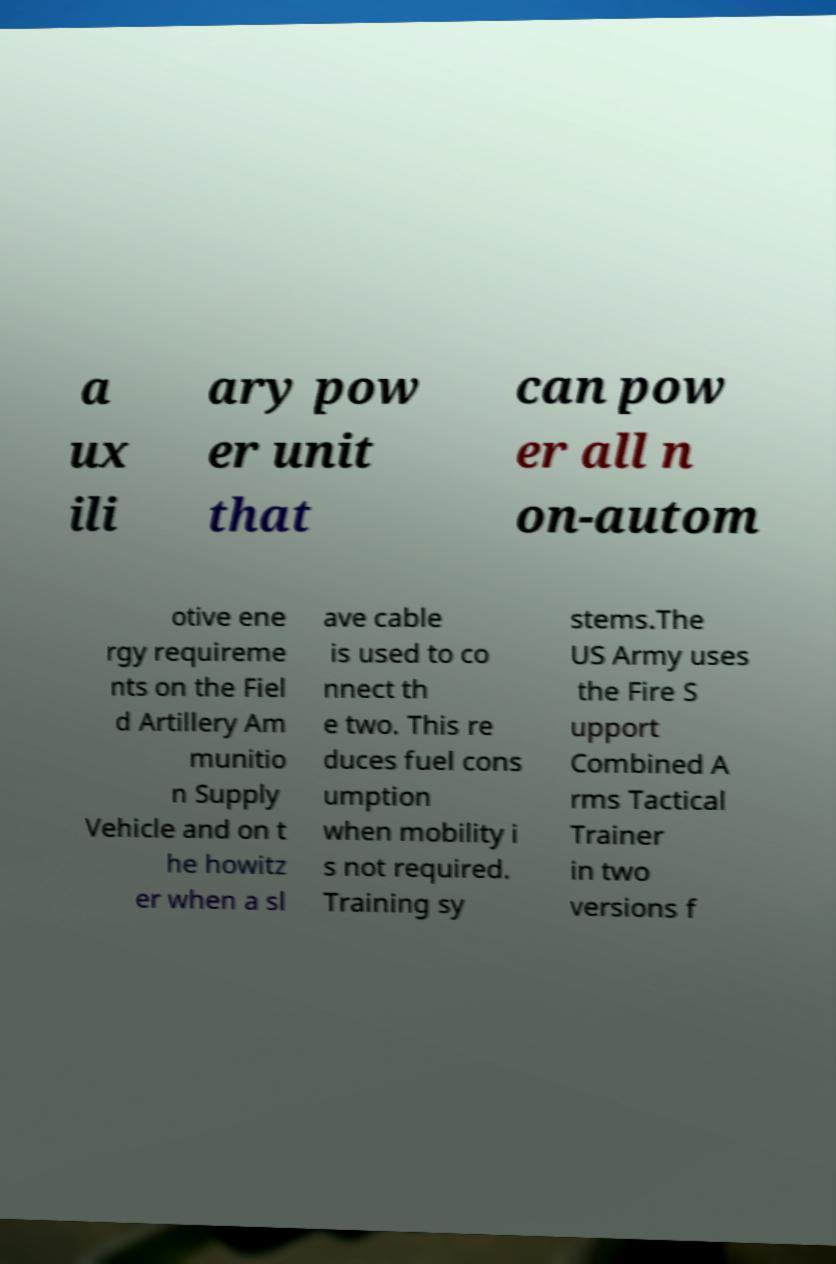Can you accurately transcribe the text from the provided image for me? a ux ili ary pow er unit that can pow er all n on-autom otive ene rgy requireme nts on the Fiel d Artillery Am munitio n Supply Vehicle and on t he howitz er when a sl ave cable is used to co nnect th e two. This re duces fuel cons umption when mobility i s not required. Training sy stems.The US Army uses the Fire S upport Combined A rms Tactical Trainer in two versions f 